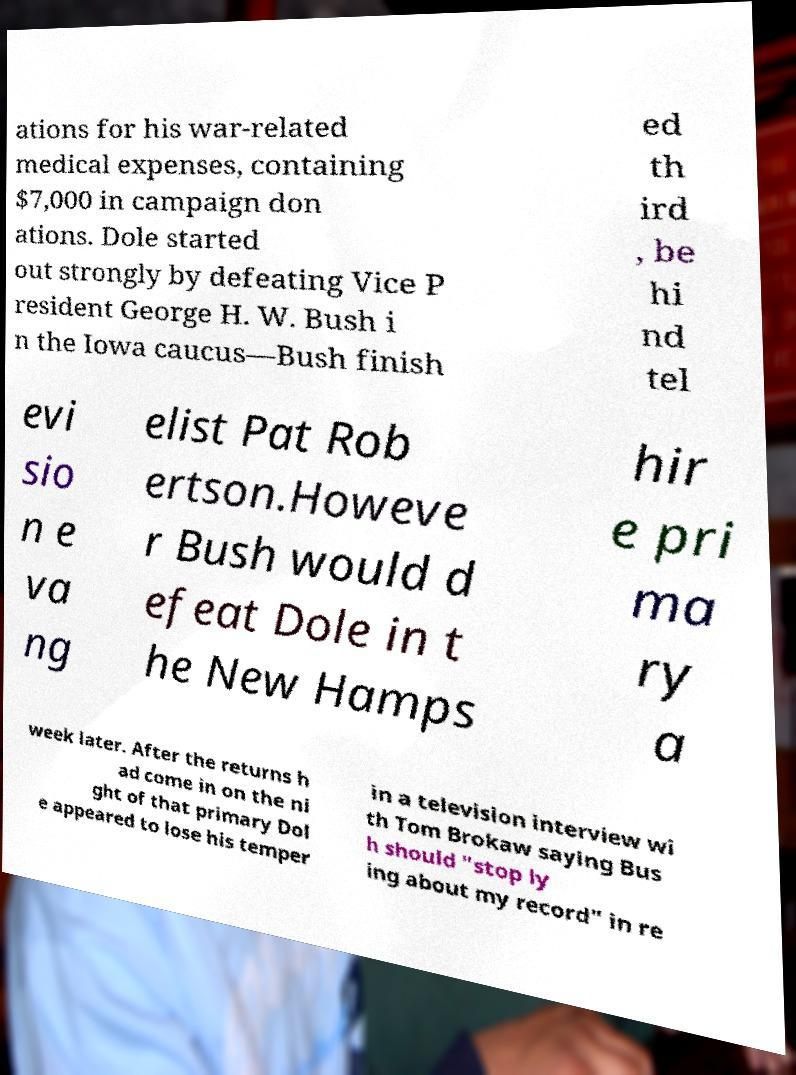Can you read and provide the text displayed in the image?This photo seems to have some interesting text. Can you extract and type it out for me? ations for his war-related medical expenses, containing $7,000 in campaign don ations. Dole started out strongly by defeating Vice P resident George H. W. Bush i n the Iowa caucus—Bush finish ed th ird , be hi nd tel evi sio n e va ng elist Pat Rob ertson.Howeve r Bush would d efeat Dole in t he New Hamps hir e pri ma ry a week later. After the returns h ad come in on the ni ght of that primary Dol e appeared to lose his temper in a television interview wi th Tom Brokaw saying Bus h should "stop ly ing about my record" in re 